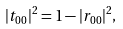<formula> <loc_0><loc_0><loc_500><loc_500>| t _ { 0 0 } | ^ { 2 } = 1 - | r _ { 0 0 } | ^ { 2 } ,</formula> 